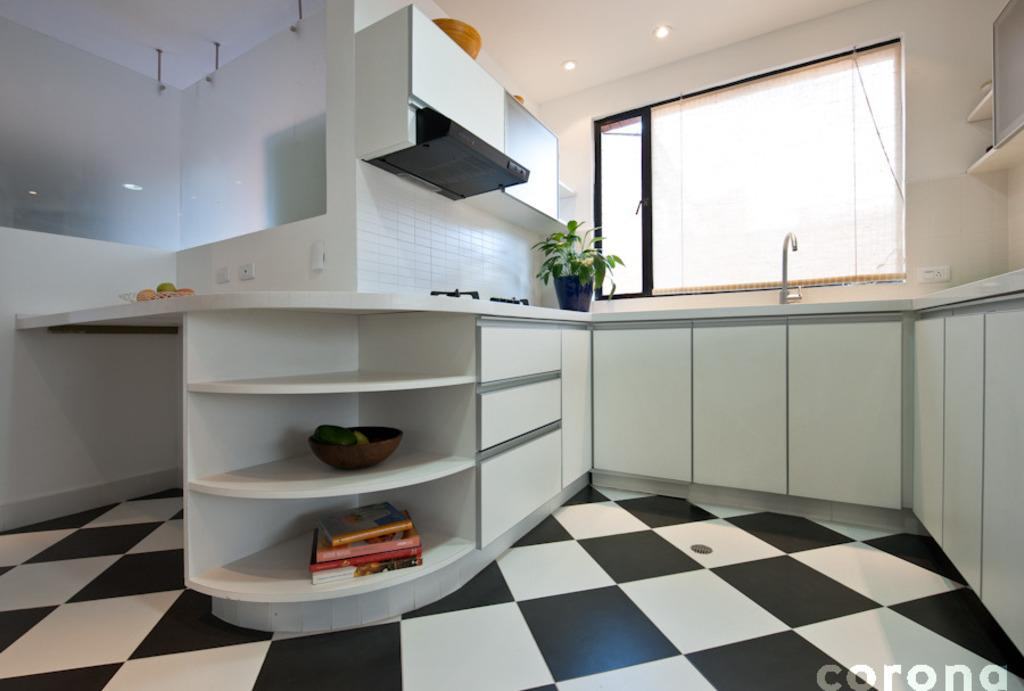What type of kitchen is shown in the image? There is a modular kitchen in the image. What appliance can be seen in the kitchen? There is a stove in the kitchen. What feature is present to remove smoke or steam from the kitchen? There is a chimney in the kitchen. What items are visible in the image that are not related to the kitchen? There are books in the image. What type of window is present in the image? There is a glass window in the image. What material is used for the floor in the kitchen? There is a marble floor in the image. What type of storage is available in the kitchen? There are cupboards in the kitchen. What type of hat is the pig wearing in the image? There is no pig or hat present in the image. 